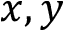<formula> <loc_0><loc_0><loc_500><loc_500>x , y</formula> 